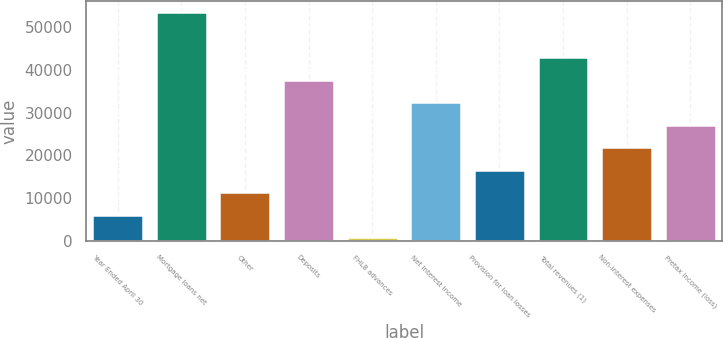Convert chart to OTSL. <chart><loc_0><loc_0><loc_500><loc_500><bar_chart><fcel>Year Ended April 30<fcel>Mortgage loans net<fcel>Other<fcel>Deposits<fcel>FHLB advances<fcel>Net interest income<fcel>Provision for loan losses<fcel>Total revenues (1)<fcel>Non-interest expenses<fcel>Pretax income (loss)<nl><fcel>6092<fcel>53396<fcel>11348<fcel>37628<fcel>836<fcel>32372<fcel>16604<fcel>42884<fcel>21860<fcel>27116<nl></chart> 